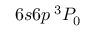<formula> <loc_0><loc_0><loc_500><loc_500>6 s 6 p \, ^ { 3 } P _ { 0 }</formula> 